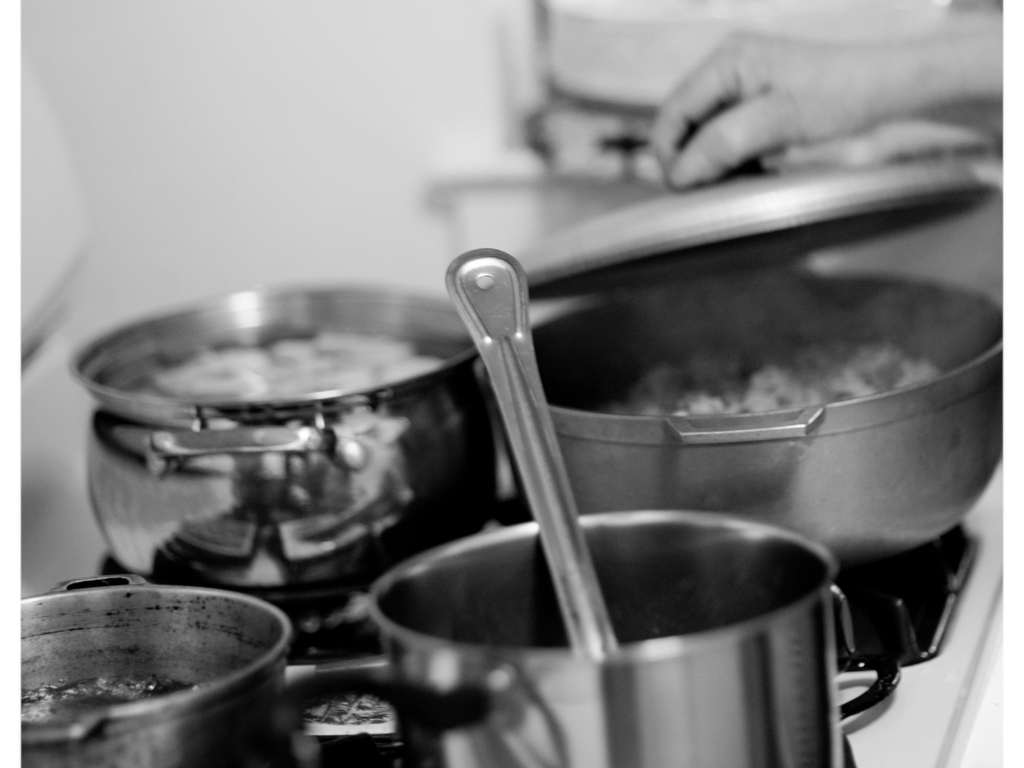Can you discuss the choice of black and white for this kitchen scene? The choice of black and white for the photograph strips down distractions, focusing the viewer on the textures, lighting, and the essence of the scene rather than the colors. This artistic decision amplifies the timeless quality of the cooking environment and highlights the contrasts and details, such as the reflective surfaces of the pots and the opacity of the steam, enhancing the visual drama and emotional impact of the scene. 